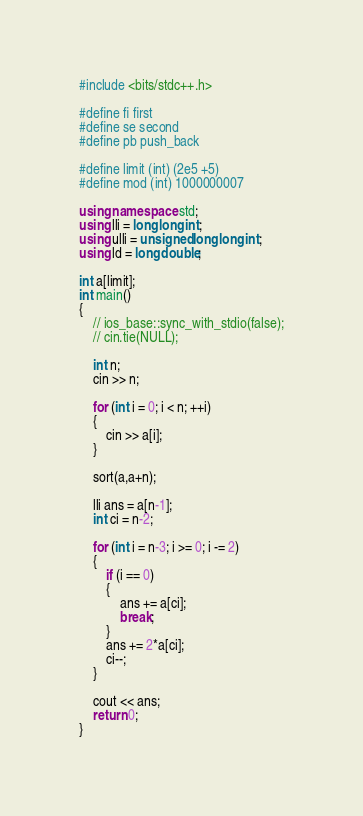Convert code to text. <code><loc_0><loc_0><loc_500><loc_500><_C++_>#include <bits/stdc++.h>
 
#define fi first
#define se second
#define pb push_back
 
#define limit (int) (2e5 +5)
#define mod (int) 1000000007

using namespace std;
using lli = long long int;
using ulli = unsigned long long int;
using ld = long double;

int a[limit];
int main()
{
    // ios_base::sync_with_stdio(false);
    // cin.tie(NULL);
    
    int n;
    cin >> n;

    for (int i = 0; i < n; ++i)
    {
        cin >> a[i];
    }

    sort(a,a+n);

    lli ans = a[n-1];
    int ci = n-2;
 
    for (int i = n-3; i >= 0; i -= 2)
    {
        if (i == 0)
        {
            ans += a[ci];
            break;
        }
        ans += 2*a[ci];
        ci--;
    }

    cout << ans;
    return 0;
}














</code> 